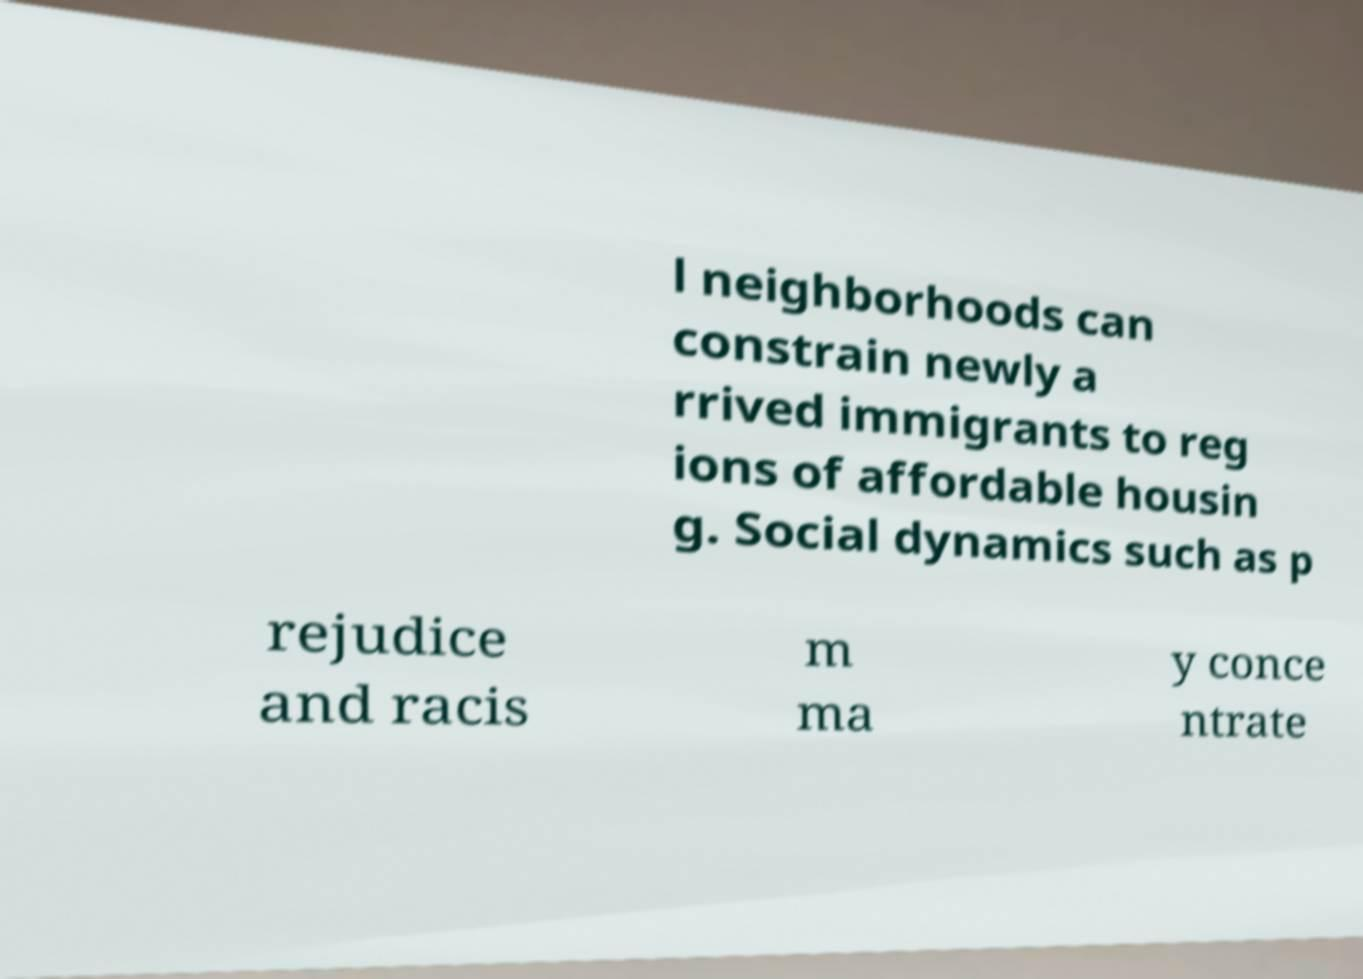Can you read and provide the text displayed in the image?This photo seems to have some interesting text. Can you extract and type it out for me? l neighborhoods can constrain newly a rrived immigrants to reg ions of affordable housin g. Social dynamics such as p rejudice and racis m ma y conce ntrate 